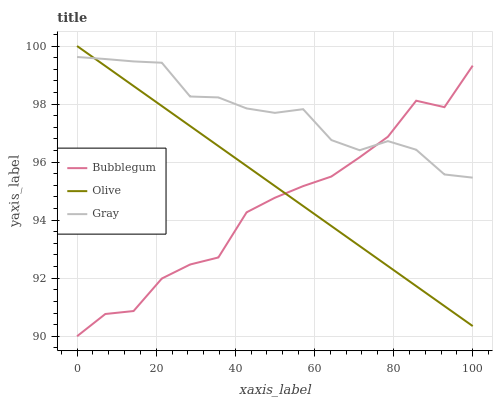Does Bubblegum have the minimum area under the curve?
Answer yes or no. Yes. Does Gray have the maximum area under the curve?
Answer yes or no. Yes. Does Gray have the minimum area under the curve?
Answer yes or no. No. Does Bubblegum have the maximum area under the curve?
Answer yes or no. No. Is Olive the smoothest?
Answer yes or no. Yes. Is Bubblegum the roughest?
Answer yes or no. Yes. Is Gray the smoothest?
Answer yes or no. No. Is Gray the roughest?
Answer yes or no. No. Does Bubblegum have the lowest value?
Answer yes or no. Yes. Does Gray have the lowest value?
Answer yes or no. No. Does Olive have the highest value?
Answer yes or no. Yes. Does Gray have the highest value?
Answer yes or no. No. Does Bubblegum intersect Gray?
Answer yes or no. Yes. Is Bubblegum less than Gray?
Answer yes or no. No. Is Bubblegum greater than Gray?
Answer yes or no. No. 